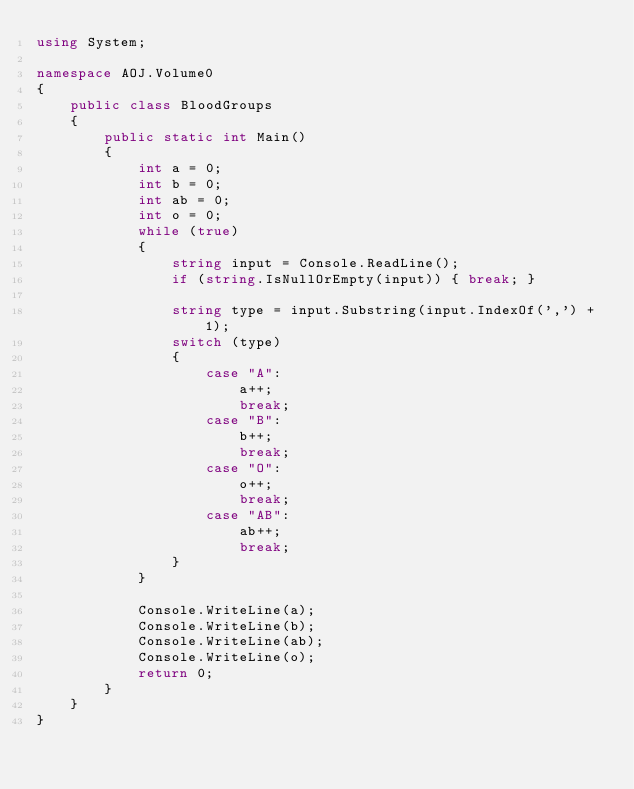Convert code to text. <code><loc_0><loc_0><loc_500><loc_500><_C#_>using System;

namespace AOJ.Volume0
{
    public class BloodGroups
    {
        public static int Main()
        {
            int a = 0;
            int b = 0;
            int ab = 0;
            int o = 0;
            while (true)
            {
                string input = Console.ReadLine();
                if (string.IsNullOrEmpty(input)) { break; }

                string type = input.Substring(input.IndexOf(',') + 1);
                switch (type)
                {
                    case "A":
                        a++;
                        break;
                    case "B":
                        b++;
                        break;
                    case "O":
                        o++;
                        break;
                    case "AB":
                        ab++;
                        break;
                }
            }

            Console.WriteLine(a);
            Console.WriteLine(b);
            Console.WriteLine(ab);
            Console.WriteLine(o);
            return 0;
        }
    }
}</code> 